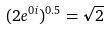Convert formula to latex. <formula><loc_0><loc_0><loc_500><loc_500>( 2 e ^ { 0 i } ) ^ { 0 . 5 } = \sqrt { 2 }</formula> 